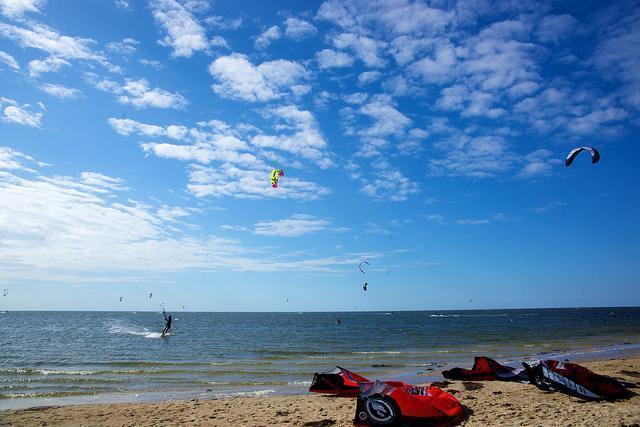What is in the sky?
Select the accurate answer and provide explanation: 'Answer: answer
Rationale: rationale.'
Options: Egg, kite, frisbee, rocket. Answer: kite.
Rationale: There are some kites and parasails up in the sky. 